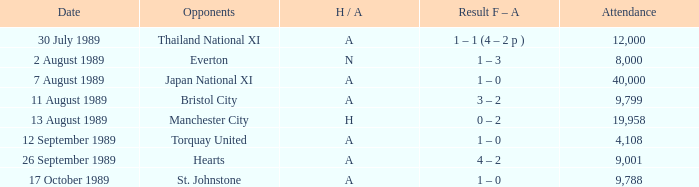When did manchester united encounter bristol city with an h/a of a? 11 August 1989. 